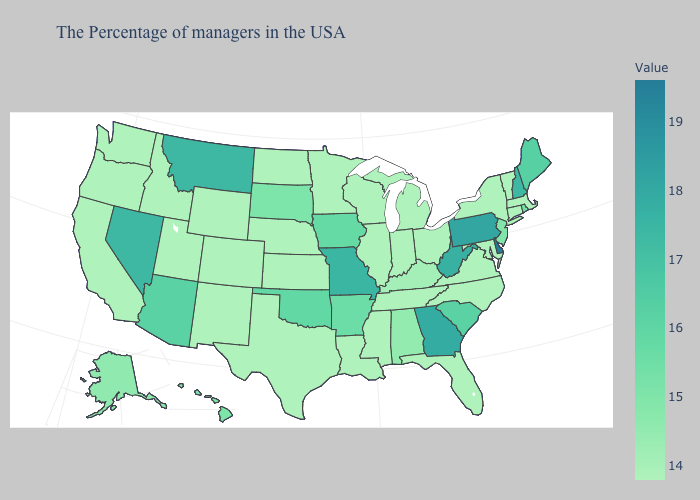Among the states that border New Mexico , which have the highest value?
Answer briefly. Arizona. Does Connecticut have the highest value in the Northeast?
Keep it brief. No. Among the states that border Iowa , which have the highest value?
Short answer required. Missouri. Does Massachusetts have the lowest value in the Northeast?
Write a very short answer. Yes. Which states have the lowest value in the USA?
Concise answer only. Massachusetts, Vermont, Connecticut, New York, Maryland, Virginia, North Carolina, Ohio, Florida, Michigan, Indiana, Tennessee, Wisconsin, Illinois, Mississippi, Louisiana, Minnesota, Kansas, Nebraska, Texas, North Dakota, Wyoming, Colorado, New Mexico, Utah, Idaho, California, Washington, Oregon. 